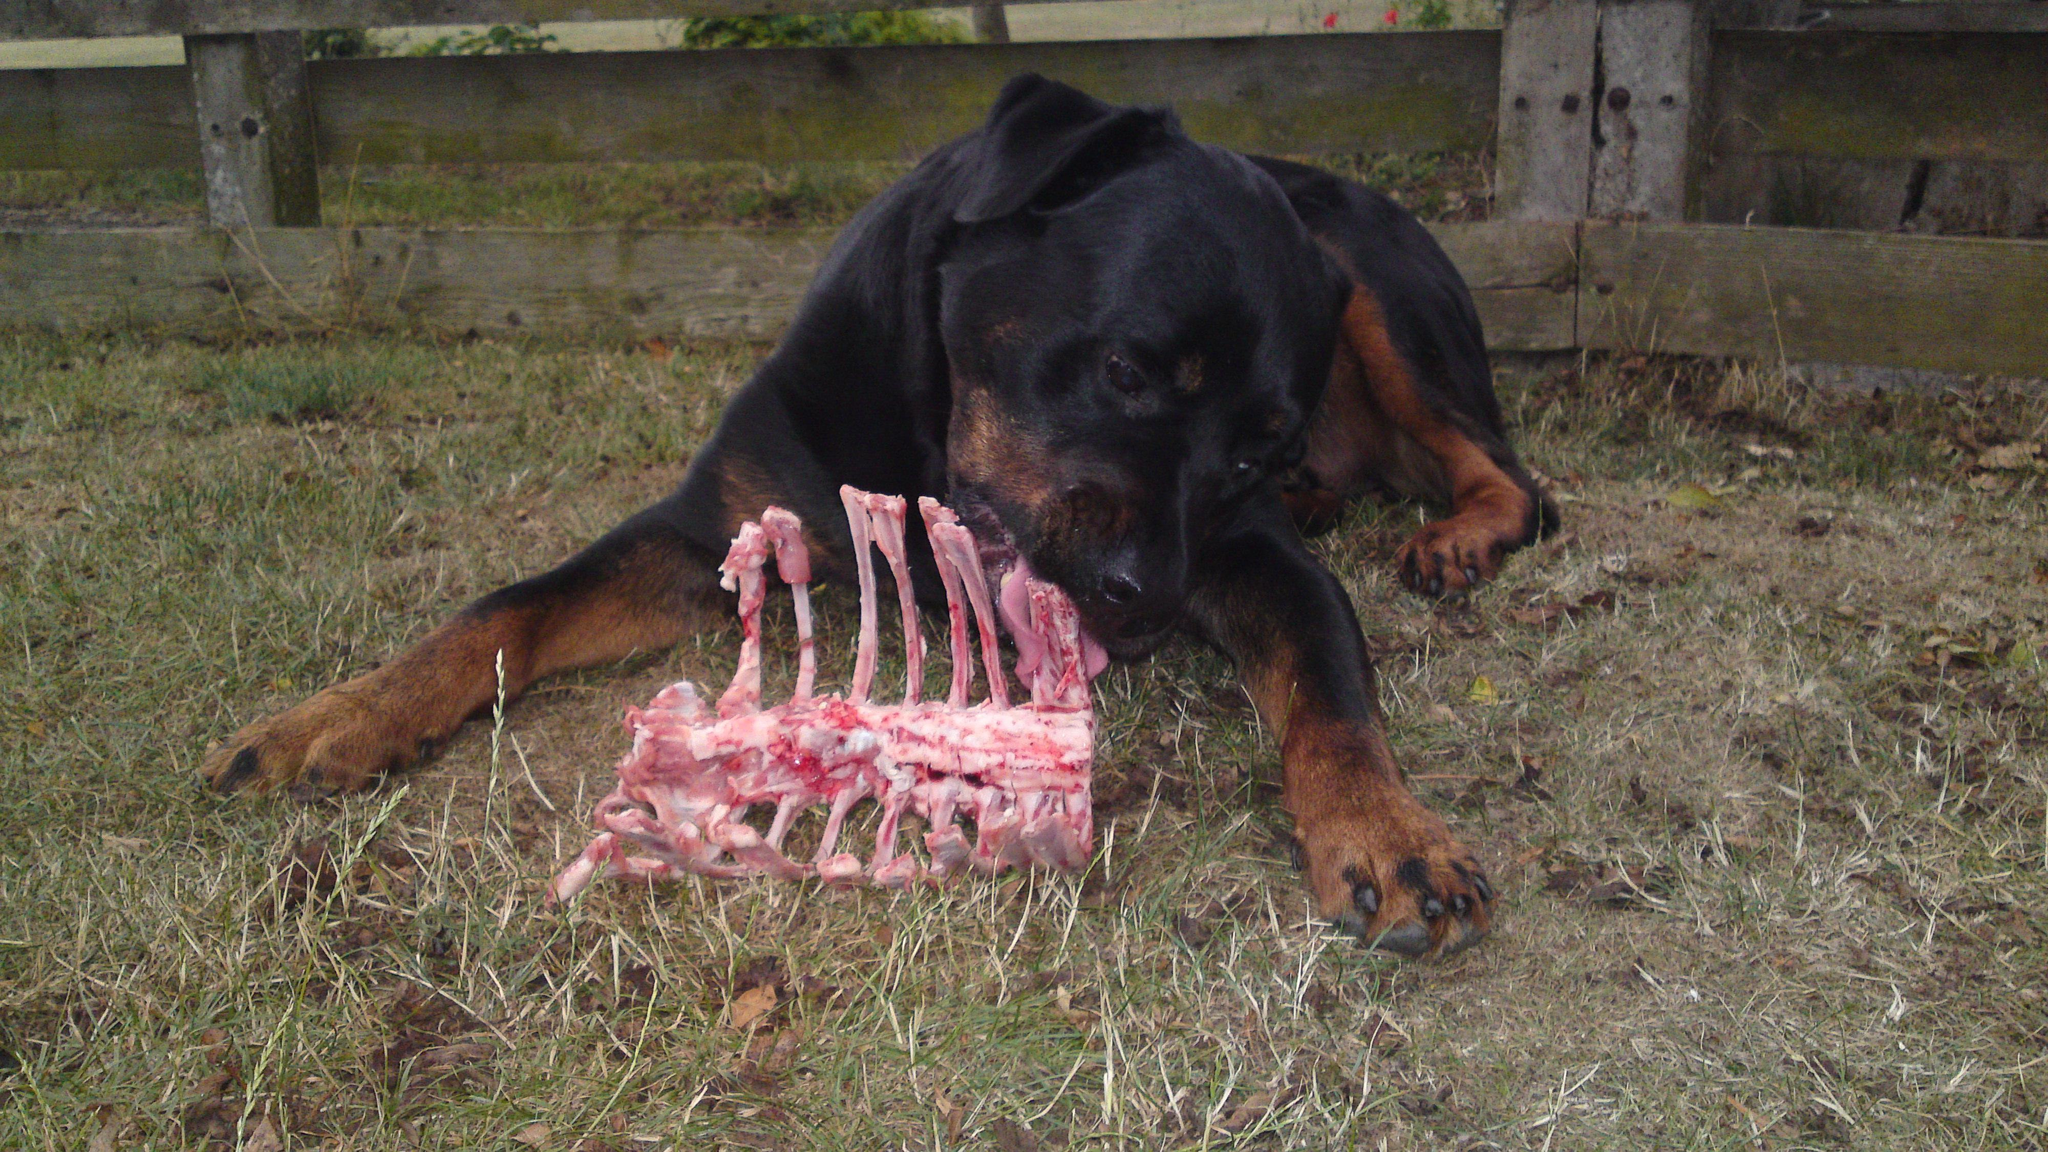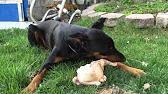The first image is the image on the left, the second image is the image on the right. For the images displayed, is the sentence "The right image features one doberman with its front paws forward on the ground and its mouth on a pale object on the grass." factually correct? Answer yes or no. Yes. The first image is the image on the left, the second image is the image on the right. Assess this claim about the two images: "Two dogs are laying in grass.". Correct or not? Answer yes or no. Yes. 